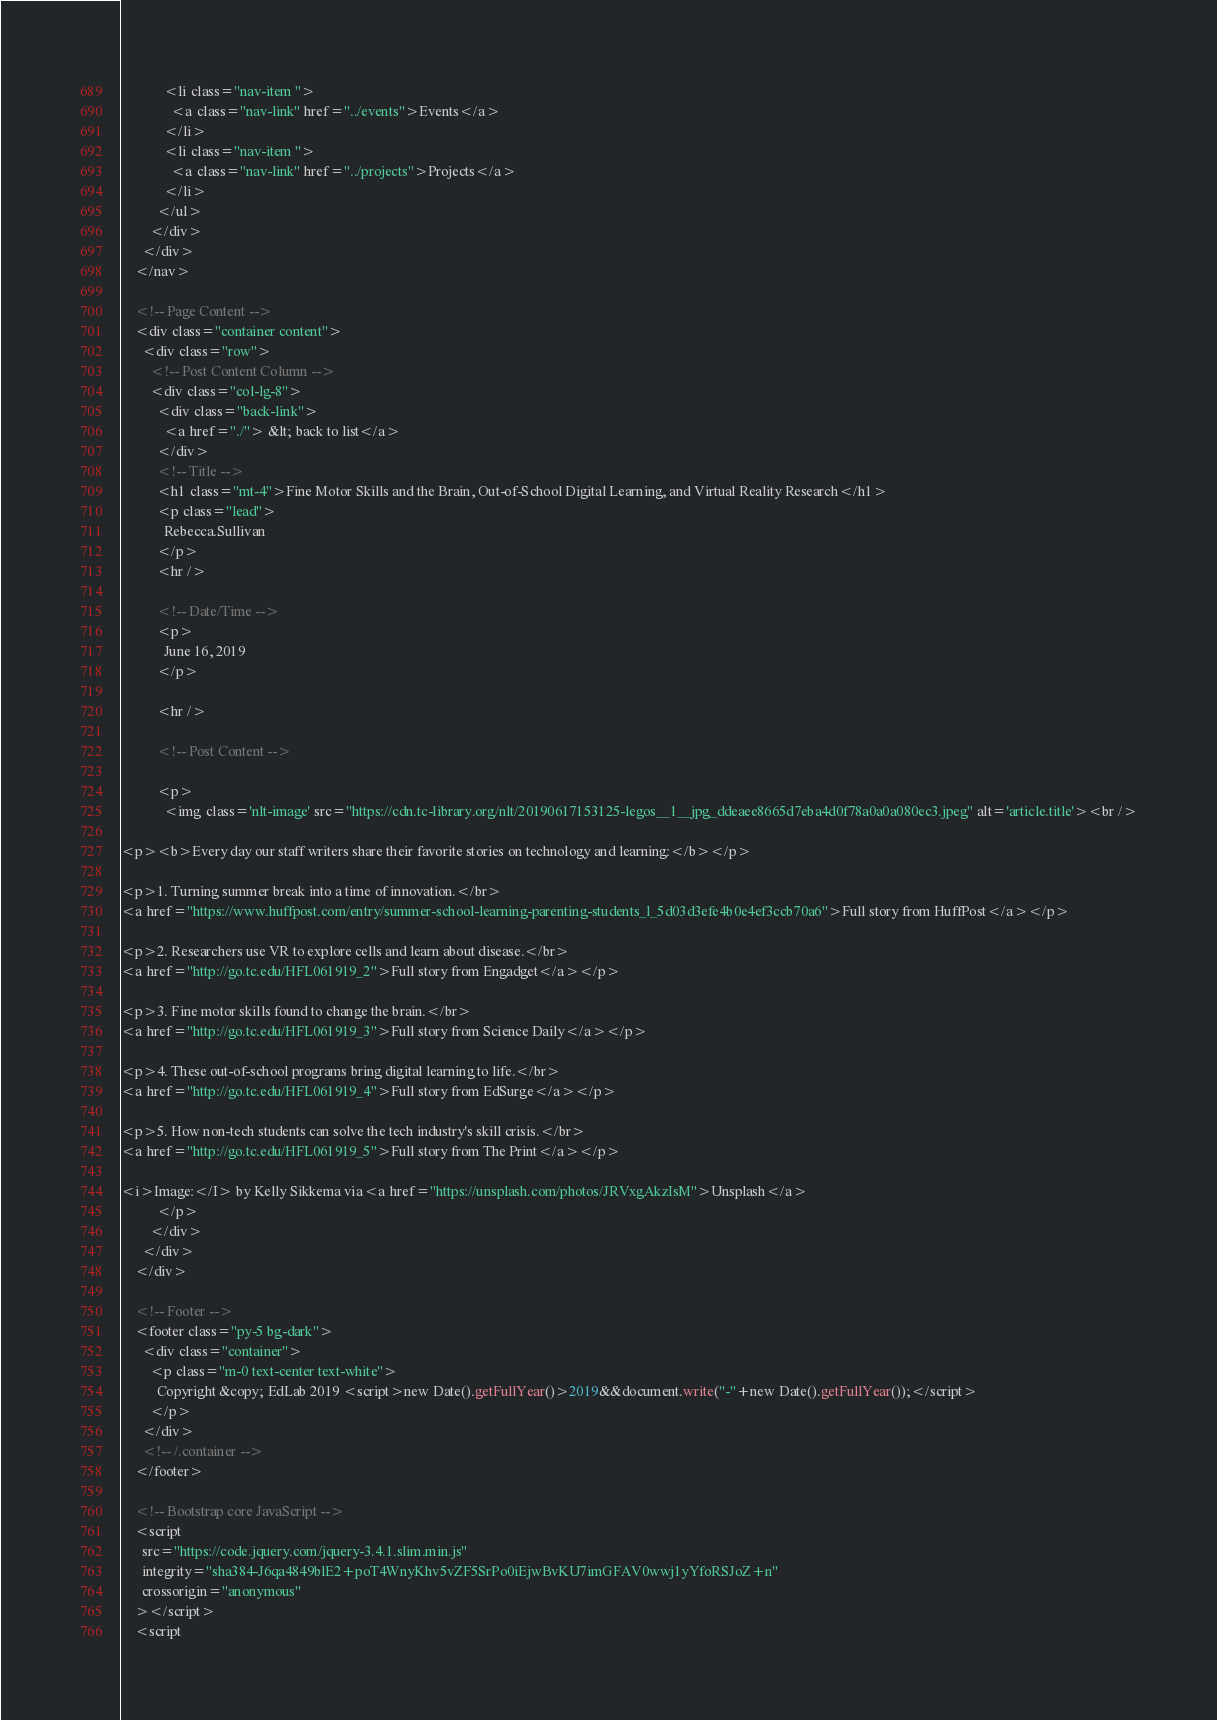Convert code to text. <code><loc_0><loc_0><loc_500><loc_500><_HTML_>            <li class="nav-item ">
              <a class="nav-link" href="../events">Events</a>
            </li>
            <li class="nav-item ">
              <a class="nav-link" href="../projects">Projects</a>
            </li>
          </ul>
        </div>
      </div>
    </nav>

    <!-- Page Content -->
    <div class="container content">
      <div class="row">
        <!-- Post Content Column -->
        <div class="col-lg-8">
          <div class="back-link">
            <a href="./"> &lt; back to list</a>
          </div>
          <!-- Title -->
          <h1 class="mt-4">Fine Motor Skills and the Brain, Out-of-School Digital Learning, and Virtual Reality Research</h1>
          <p class="lead">
            Rebecca.Sullivan
          </p>
          <hr />

          <!-- Date/Time -->
          <p>
            June 16, 2019
          </p>

          <hr />

          <!-- Post Content -->

          <p>
            <img class='nlt-image' src="https://cdn.tc-library.org/nlt/20190617153125-legos__1__jpg_ddeaee8665d7eba4d0f78a0a0a080ec3.jpeg" alt='article.title'><br />

<p><b>Every day our staff writers share their favorite stories on technology and learning:</b></p>

<p>1. Turning summer break into a time of innovation.</br>
<a href="https://www.huffpost.com/entry/summer-school-learning-parenting-students_l_5d03d3efe4b0e4ef3ccb70a6">Full story from HuffPost</a></p>

<p>2. Researchers use VR to explore cells and learn about disease.</br>
<a href="http://go.tc.edu/HFL061919_2">Full story from Engadget</a></p>

<p>3. Fine motor skills found to change the brain.</br>
<a href="http://go.tc.edu/HFL061919_3">Full story from Science Daily</a></p>

<p>4. These out-of-school programs bring digital learning to life.</br>
<a href="http://go.tc.edu/HFL061919_4">Full story from EdSurge</a></p>

<p>5. How non-tech students can solve the tech industry's skill crisis.</br>
<a href="http://go.tc.edu/HFL061919_5">Full story from The Print</a></p>

<i>Image:</I> by Kelly Sikkema via<a href="https://unsplash.com/photos/JRVxgAkzIsM">Unsplash</a>
          </p>
        </div>
      </div>
    </div>

    <!-- Footer -->
    <footer class="py-5 bg-dark">
      <div class="container">
        <p class="m-0 text-center text-white">
          Copyright &copy; EdLab 2019 <script>new Date().getFullYear()>2019&&document.write("-"+new Date().getFullYear());</script>
        </p>
      </div>
      <!-- /.container -->
    </footer>

    <!-- Bootstrap core JavaScript -->
    <script
      src="https://code.jquery.com/jquery-3.4.1.slim.min.js"
      integrity="sha384-J6qa4849blE2+poT4WnyKhv5vZF5SrPo0iEjwBvKU7imGFAV0wwj1yYfoRSJoZ+n"
      crossorigin="anonymous"
    ></script>
    <script</code> 